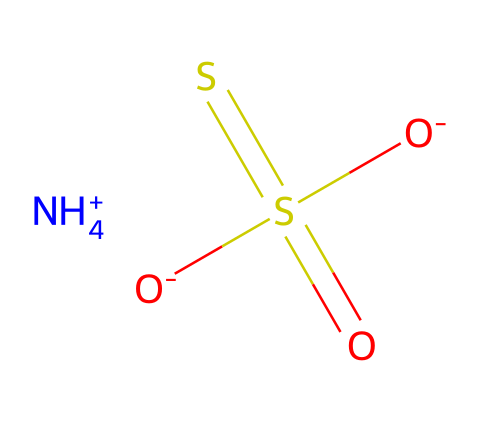What is the total number of oxygen atoms in ammonium thiosulfate? The SMILES representation shows a total of four oxygen atoms, as indicated by the "[O-]" notations and the "=O" bond in the compound structure.
Answer: four How many sulfur atoms are present in the structure? In the SMILES, there are two sulfur atoms, one represented within the "S(=O)(=S)" notation, which indicates both are bonded to different parts of the molecule.
Answer: two What is the overall charge of ammonium thiosulfate? The presence of "[NH4+]" indicates a positive charge from the ammonium ion, and the two "[O-]" denote negative charges. The overall charge sums up to zero, indicating the compound is neutral.
Answer: zero What does the "S(=O)(=S)" part of the molecule signify? The "S(=O)(=S)" part indicates that the sulfur atom is bonded to two other sulfur atoms by double bonds, and one is doubly bonded to an oxygen. This indicates a thiosulfate group.
Answer: thiosulfate group Which part of the molecule represents the ammonium? The "[NH4+]" in the SMILES explicitly represents the ammonium ion, which is a recognizable functional group commonly found in various chemical compounds.
Answer: ammonium ion What type of bonding is present between the sulfur and oxygen in ammonium thiosulfate? The "S(=O)" notation shows that there are double bonds between sulfur and oxygen, indicating covalent bonding, which is typical for such sulfur compounds.
Answer: covalent bonding How can this chemical be categorized in environmental chemistry? Ammonium thiosulfate is often classified as a sulfur compound, specifically a sulfur nutrient, which can impact soil chemistry and is relevant in waste management and recycling practices.
Answer: sulfur compound 